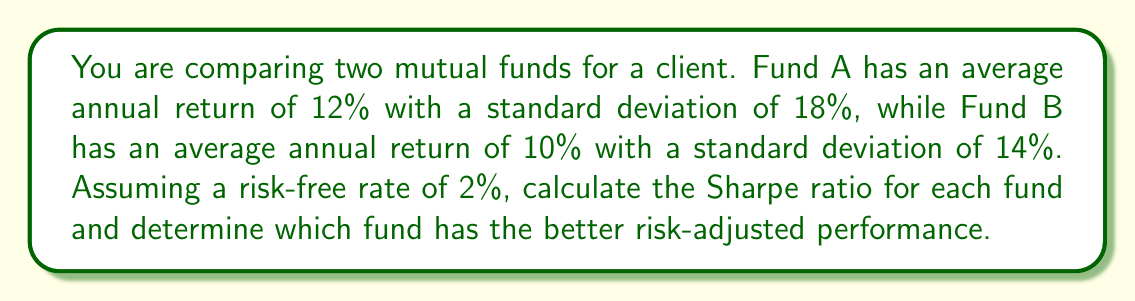What is the answer to this math problem? To solve this problem, we'll use the Sharpe ratio formula for each fund and compare the results. The Sharpe ratio is calculated as:

$$ \text{Sharpe Ratio} = \frac{R_p - R_f}{\sigma_p} $$

Where:
$R_p$ = Portfolio return
$R_f$ = Risk-free rate
$\sigma_p$ = Portfolio standard deviation

Step 1: Calculate the Sharpe ratio for Fund A
$$ \text{Sharpe Ratio}_A = \frac{12\% - 2\%}{18\%} = \frac{10\%}{18\%} = 0.5556 $$

Step 2: Calculate the Sharpe ratio for Fund B
$$ \text{Sharpe Ratio}_B = \frac{10\% - 2\%}{14\%} = \frac{8\%}{14\%} = 0.5714 $$

Step 3: Compare the Sharpe ratios
Fund B has a higher Sharpe ratio (0.5714) compared to Fund A (0.5556), indicating that Fund B has better risk-adjusted performance.
Answer: Fund B (Sharpe ratio: 0.5714) 